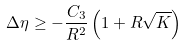Convert formula to latex. <formula><loc_0><loc_0><loc_500><loc_500>\Delta \eta \geq - \frac { C _ { 3 } } { R ^ { 2 } } \left ( 1 + R \sqrt { K } \right )</formula> 